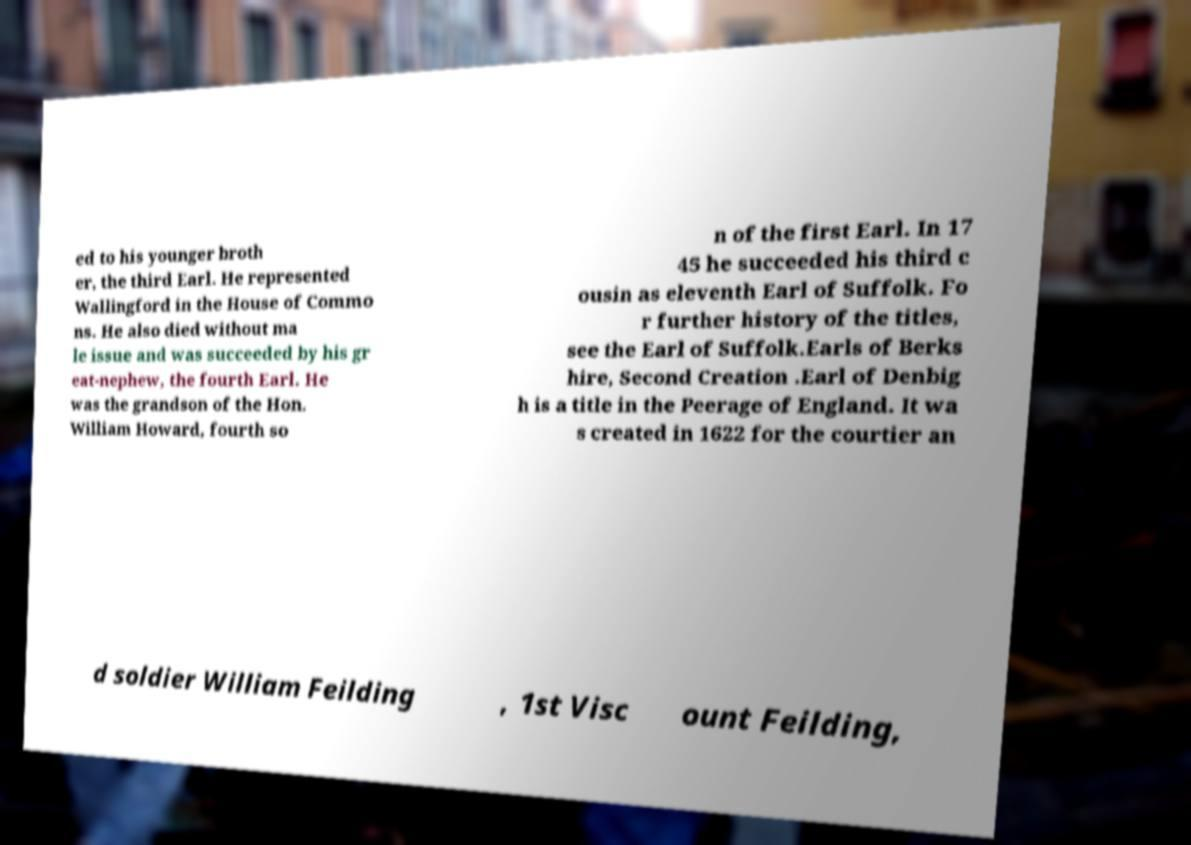Can you accurately transcribe the text from the provided image for me? ed to his younger broth er, the third Earl. He represented Wallingford in the House of Commo ns. He also died without ma le issue and was succeeded by his gr eat-nephew, the fourth Earl. He was the grandson of the Hon. William Howard, fourth so n of the first Earl. In 17 45 he succeeded his third c ousin as eleventh Earl of Suffolk. Fo r further history of the titles, see the Earl of Suffolk.Earls of Berks hire, Second Creation .Earl of Denbig h is a title in the Peerage of England. It wa s created in 1622 for the courtier an d soldier William Feilding , 1st Visc ount Feilding, 